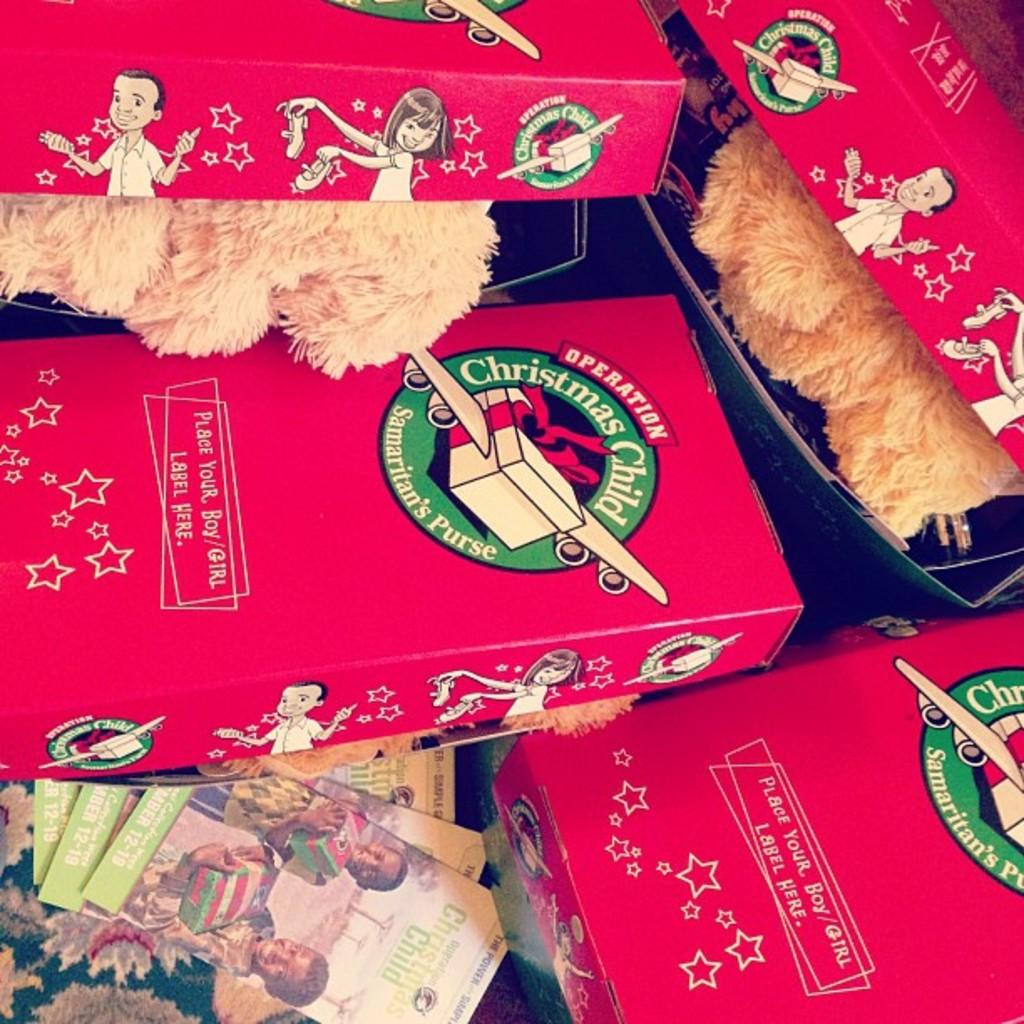What objects are present in the image? There are toys in the image. How are the toys arranged or stored in the image? The toys are in boxes. What type of lettuce is being used to help organize the toys in the image? There is no lettuce present in the image, and the toys are organized in boxes, not lettuce. 